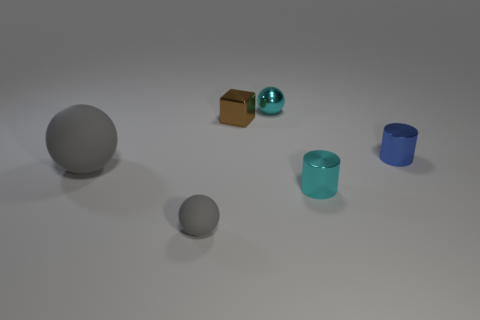How would you describe the atmosphere or mood conveyed by the arrangement and lighting of these objects? The arrangement and soft lighting create a calm and minimalistic atmosphere. The objects are spaced out in a seemingly random yet balanced manner, which could imply a sense of serenity or order within an open space. 